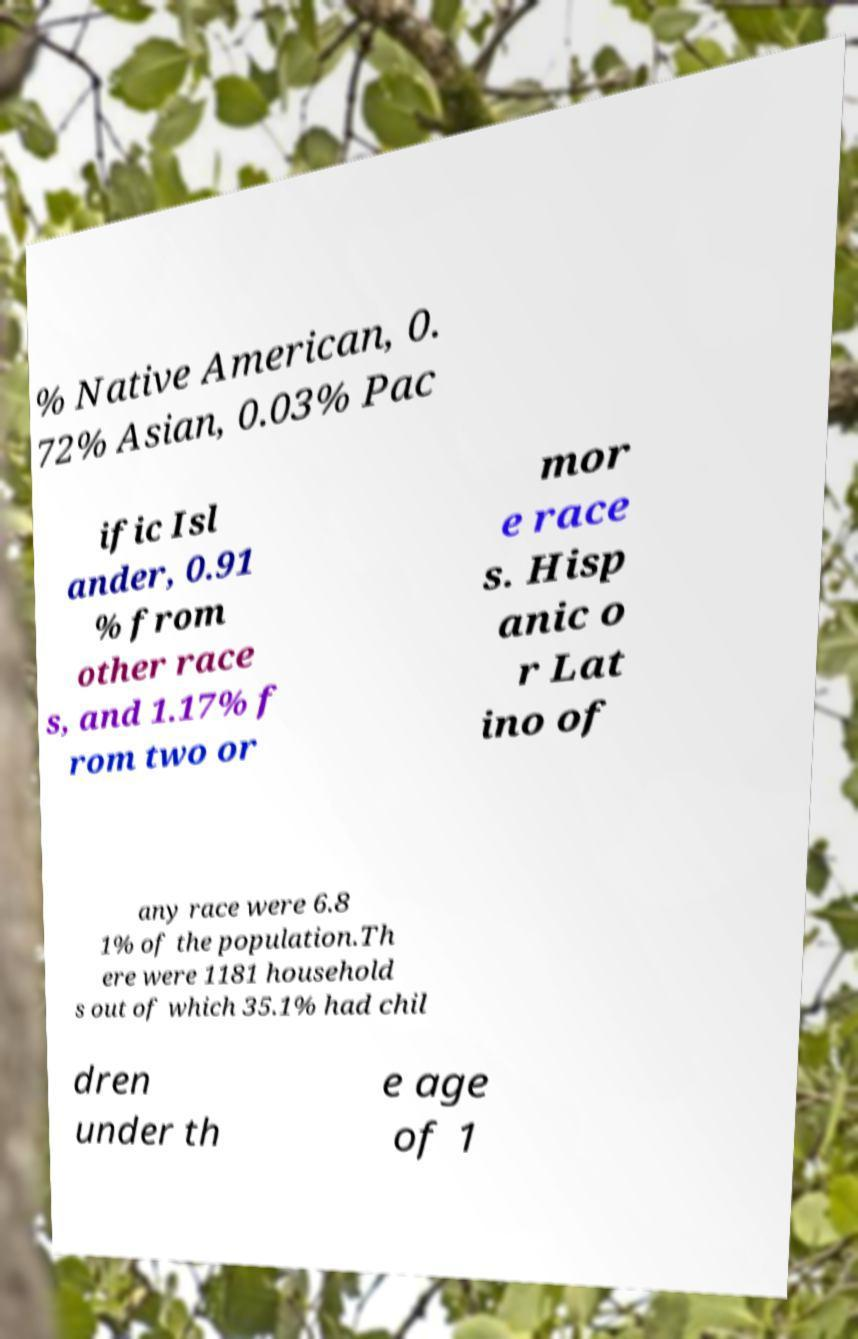Could you extract and type out the text from this image? % Native American, 0. 72% Asian, 0.03% Pac ific Isl ander, 0.91 % from other race s, and 1.17% f rom two or mor e race s. Hisp anic o r Lat ino of any race were 6.8 1% of the population.Th ere were 1181 household s out of which 35.1% had chil dren under th e age of 1 